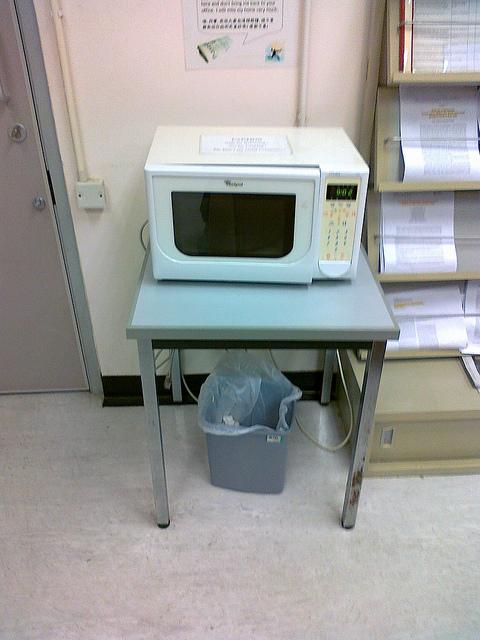What is the microwave sitting on?
Concise answer only. Table. What is on the microwave?
Concise answer only. Instructions. Is the microwave old?
Quick response, please. Yes. 